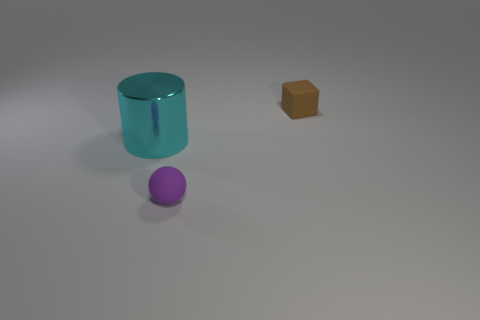Add 3 metal things. How many objects exist? 6 Subtract all blocks. How many objects are left? 2 Add 2 green metal objects. How many green metal objects exist? 2 Subtract 0 yellow balls. How many objects are left? 3 Subtract all tiny cylinders. Subtract all small brown cubes. How many objects are left? 2 Add 3 metallic cylinders. How many metallic cylinders are left? 4 